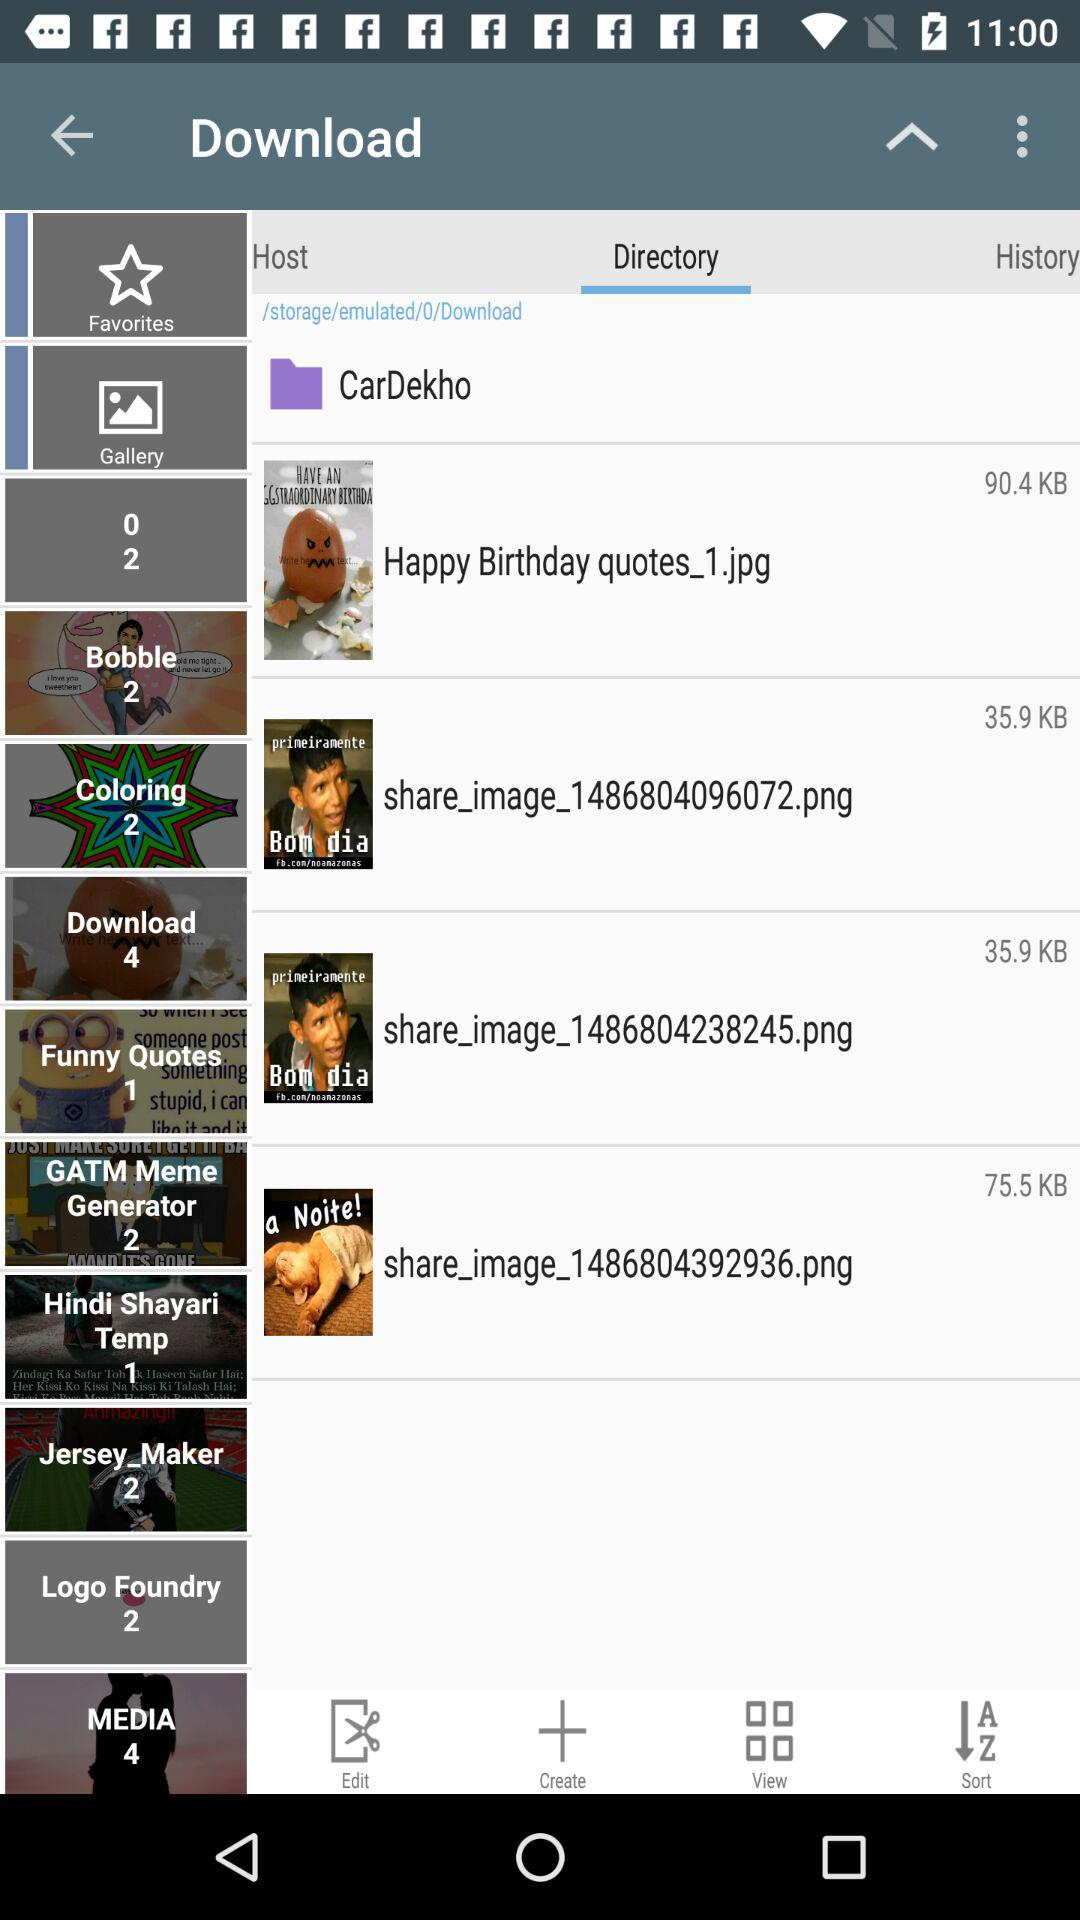How many total items are there in "Download"? There are a total of 4 items. 